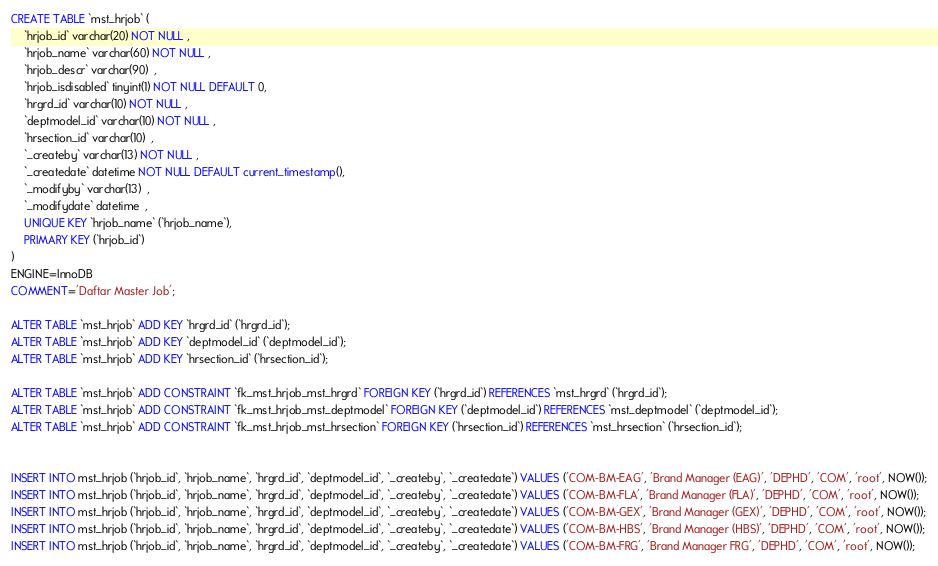Convert code to text. <code><loc_0><loc_0><loc_500><loc_500><_SQL_>CREATE TABLE `mst_hrjob` (
	`hrjob_id` varchar(20) NOT NULL , 
	`hrjob_name` varchar(60) NOT NULL , 
	`hrjob_descr` varchar(90)  , 
	`hrjob_isdisabled` tinyint(1) NOT NULL DEFAULT 0, 
	`hrgrd_id` varchar(10) NOT NULL , 
	`deptmodel_id` varchar(10) NOT NULL , 
	`hrsection_id` varchar(10)  , 
	`_createby` varchar(13) NOT NULL , 
	`_createdate` datetime NOT NULL DEFAULT current_timestamp(), 
	`_modifyby` varchar(13)  , 
	`_modifydate` datetime  , 
	UNIQUE KEY `hrjob_name` (`hrjob_name`),
	PRIMARY KEY (`hrjob_id`)
) 
ENGINE=InnoDB
COMMENT='Daftar Master Job';

ALTER TABLE `mst_hrjob` ADD KEY `hrgrd_id` (`hrgrd_id`);
ALTER TABLE `mst_hrjob` ADD KEY `deptmodel_id` (`deptmodel_id`);
ALTER TABLE `mst_hrjob` ADD KEY `hrsection_id` (`hrsection_id`);

ALTER TABLE `mst_hrjob` ADD CONSTRAINT `fk_mst_hrjob_mst_hrgrd` FOREIGN KEY (`hrgrd_id`) REFERENCES `mst_hrgrd` (`hrgrd_id`);
ALTER TABLE `mst_hrjob` ADD CONSTRAINT `fk_mst_hrjob_mst_deptmodel` FOREIGN KEY (`deptmodel_id`) REFERENCES `mst_deptmodel` (`deptmodel_id`);
ALTER TABLE `mst_hrjob` ADD CONSTRAINT `fk_mst_hrjob_mst_hrsection` FOREIGN KEY (`hrsection_id`) REFERENCES `mst_hrsection` (`hrsection_id`);


INSERT INTO mst_hrjob (`hrjob_id`, `hrjob_name`, `hrgrd_id`, `deptmodel_id`, `_createby`, `_createdate`) VALUES ('COM-BM-EAG', 'Brand Manager (EAG)', 'DEPHD', 'COM', 'root', NOW());
INSERT INTO mst_hrjob (`hrjob_id`, `hrjob_name`, `hrgrd_id`, `deptmodel_id`, `_createby`, `_createdate`) VALUES ('COM-BM-FLA', 'Brand Manager (FLA)', 'DEPHD', 'COM', 'root', NOW());
INSERT INTO mst_hrjob (`hrjob_id`, `hrjob_name`, `hrgrd_id`, `deptmodel_id`, `_createby`, `_createdate`) VALUES ('COM-BM-GEX', 'Brand Manager (GEX)', 'DEPHD', 'COM', 'root', NOW());
INSERT INTO mst_hrjob (`hrjob_id`, `hrjob_name`, `hrgrd_id`, `deptmodel_id`, `_createby`, `_createdate`) VALUES ('COM-BM-HBS', 'Brand Manager (HBS)', 'DEPHD', 'COM', 'root', NOW());
INSERT INTO mst_hrjob (`hrjob_id`, `hrjob_name`, `hrgrd_id`, `deptmodel_id`, `_createby`, `_createdate`) VALUES ('COM-BM-FRG', 'Brand Manager FRG', 'DEPHD', 'COM', 'root', NOW());



</code> 